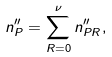Convert formula to latex. <formula><loc_0><loc_0><loc_500><loc_500>n _ { P } ^ { \prime \prime } = \sum _ { R = 0 } ^ { \nu } n _ { P R } ^ { \prime \prime } ,</formula> 